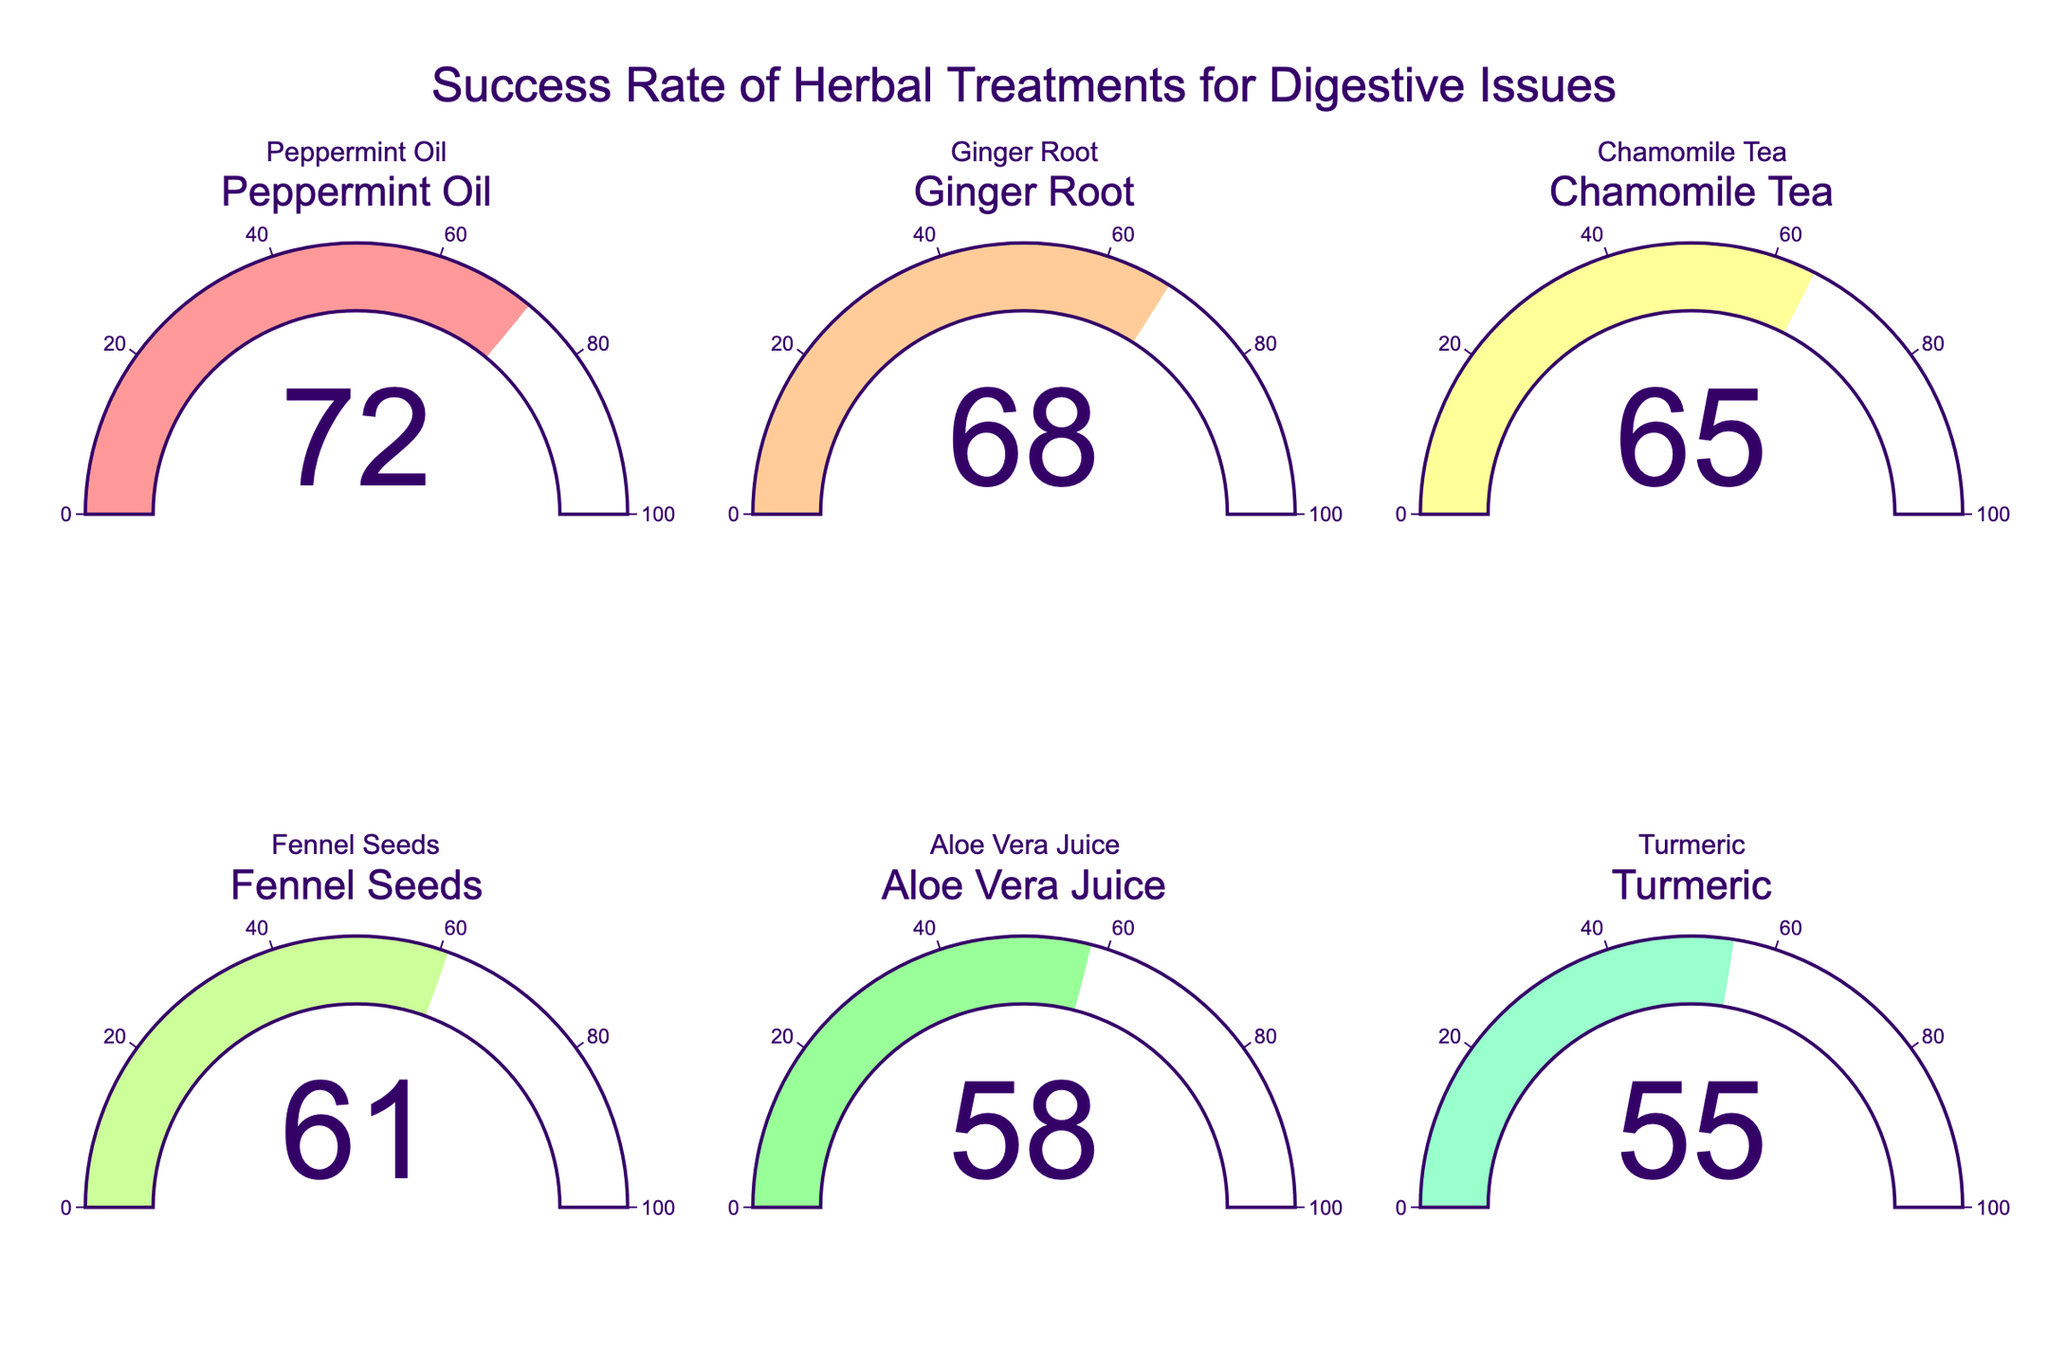What is the success rate of Peppermint Oil treatment? Look at the gauge chart labeled "Peppermint Oil" to find the success rate displayed on the gauge.
Answer: 72 Which herbal treatment has the lowest success rate? Compare each gauge chart to identify the one with the smallest number displayed. Aloe Vera Juice shows the lowest success rate.
Answer: Aloe Vera Juice How many treatments have a success rate of 60 or above? Count the number of treatments where the gauge shows a success rate of 60 or higher: Peppermint Oil (72), Ginger Root (68), Chamomile Tea (65), and Fennel Seeds (61).
Answer: 4 What is the average success rate of all treatments shown? Add the success rates of all treatments and divide by the number of treatments. (72 + 68 + 65 + 61 + 58 + 55) / 6 = 378 / 6.
Answer: 63 Which treatment has a higher success rate: Ginger Root or Chamomile Tea? Compare the success rates of Ginger Root and Chamomile Tea as displayed on their gauges. Ginger Root (68) is higher than Chamomile Tea (65).
Answer: Ginger Root By how many percentage points is the success rate of Peppermint Oil higher than Turmeric? Subtract the success rate of Turmeric from the success rate of Peppermint Oil. 72 - 55 = 17.
Answer: 17 Which range of colors is used in the gauge charts? Identify the color gradient sequence from the gauge charts. The colors range from light pink to light blue-green.
Answer: Light pink to light blue-green Are there any treatments with a 100% success rate? Look at each gauge chart to see if any of the success rates shown are 100%. None of the gauges display 100%.
Answer: No What is the difference between the highest and the lowest success rates in the chart? The highest success rate is Peppermint Oil (72) and the lowest is Aloe Vera Juice (58). Subtract the lowest from the highest. 72 - 55 = 17.
Answer: 17 